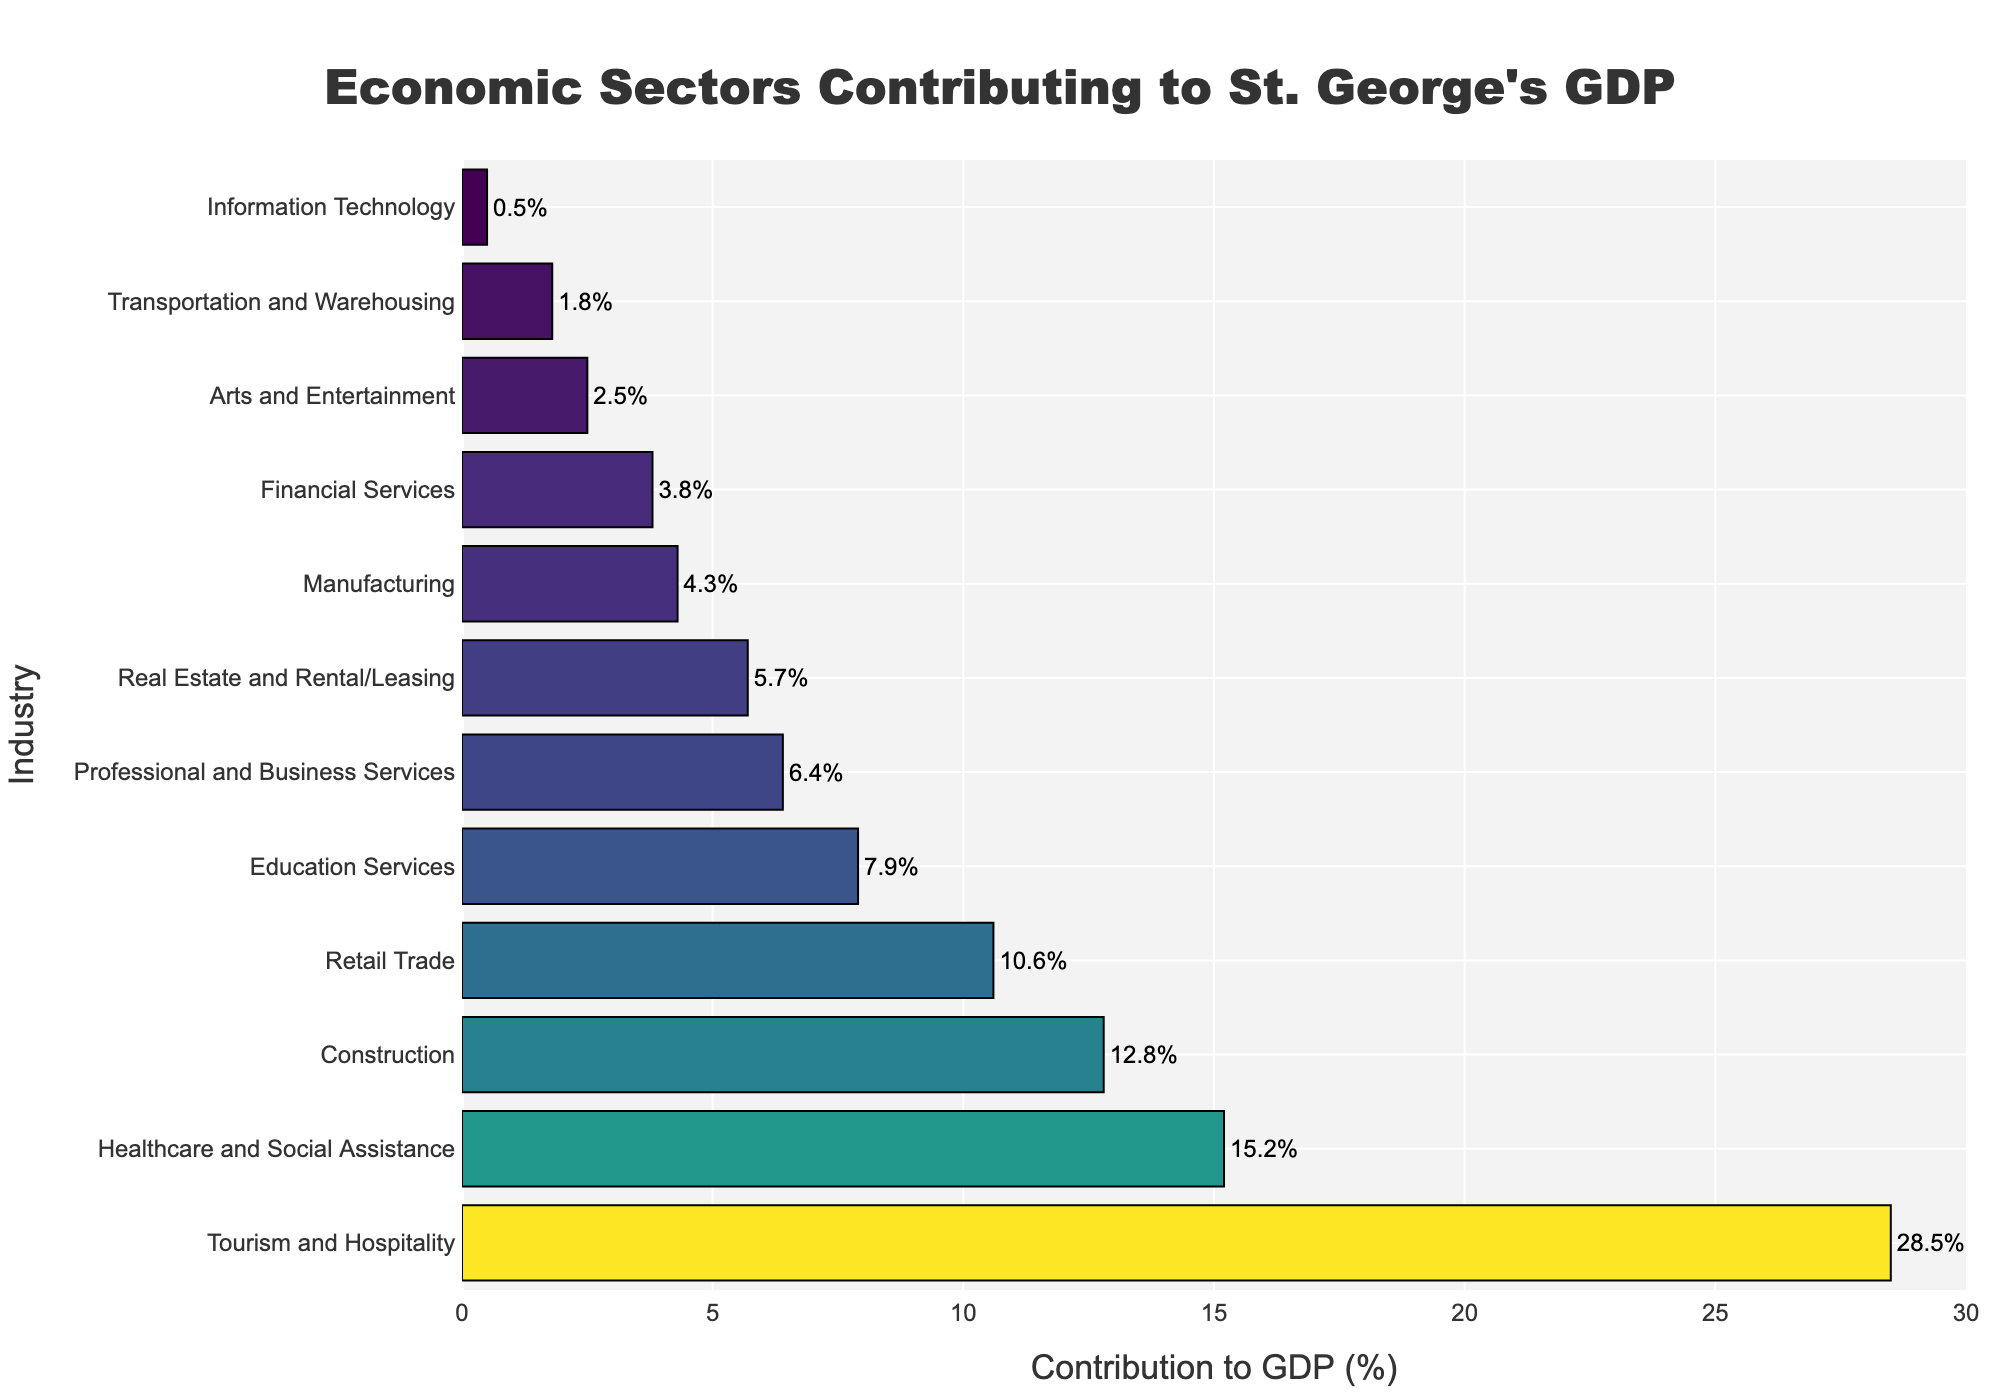Which industry contributes the most to St. George's GDP? The height of the bar in the plot that represents "Tourism and Hospitality" is the tallest, indicating it has the highest contribution percentage.
Answer: Tourism and Hospitality Which industry contributes the least to St. George's GDP? The height of the bar in the plot that represents "Information Technology" is the shortest, indicating it has the lowest contribution percentage.
Answer: Information Technology What is the difference in GDP contribution between Healthcare and Social Assistance and Retail Trade? The bar for Healthcare and Social Assistance is at 15.2%, and the bar for Retail Trade is at 10.6%. The difference is calculated as 15.2% - 10.6% = 4.6%.
Answer: 4.6% If you sum the GDP contributions of Construction and Manufacturing, what is the total? The contribution of Construction is 12.8%, and Manufacturing is 4.3%. The sum is 12.8% + 4.3% = 17.1%.
Answer: 17.1% Which industry has a contribution to GDP more than twice that of Real Estate and Rental/Leasing? The Real Estate and Rental/Leasing contribution is 5.7%. Twice that is 2 * 5.7% = 11.4%. The industries contributing more than 11.4% are Tourism and Hospitality (28.5%), Healthcare and Social Assistance (15.2%), and Construction (12.8%).
Answer: Tourism and Hospitality, Healthcare and Social Assistance, Construction What is the combined contribution of the three industries with the lowest GDP contributions? The three industries with the lowest contributions are Information Technology (0.5%), Transportation and Warehousing (1.8%), and Arts and Entertainment (2.5%). The sum is 0.5% + 1.8% + 2.5% = 4.8%.
Answer: 4.8% Which industry contributes just below Education Services in terms of GDP percentage? The bar representing Professional and Business Services is just below Education Services.
Answer: Professional and Business Services What percentage more does Tourism and Hospitality contribute compared to Professional and Business Services? The contribution of Tourism and Hospitality is 28.5% while Professional and Business Services is 6.4%. The difference is 28.5% - 6.4% = 22.1%.
Answer: 22.1% Is the GDP contribution of Arts and Entertainment greater than Financial Services? The contribution of Arts and Entertainment is 2.5%, while Financial Services is 3.8%, so no, Arts and Entertainment contributes less.
Answer: No What is the average GDP contribution of the top three contributing industries? The top three are Tourism and Hospitality (28.5%), Healthcare and Social Assistance (15.2%), and Construction (12.8%). The average is (28.5 + 15.2 + 12.8) / 3 = 56.5 / 3 = 18.83%.
Answer: 18.83% 